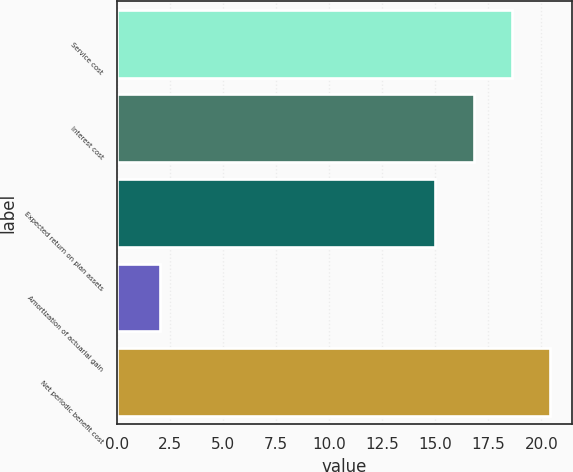Convert chart to OTSL. <chart><loc_0><loc_0><loc_500><loc_500><bar_chart><fcel>Service cost<fcel>Interest cost<fcel>Expected return on plan assets<fcel>Amortization of actuarial gain<fcel>Net periodic benefit cost<nl><fcel>18.6<fcel>16.8<fcel>15<fcel>2<fcel>20.4<nl></chart> 